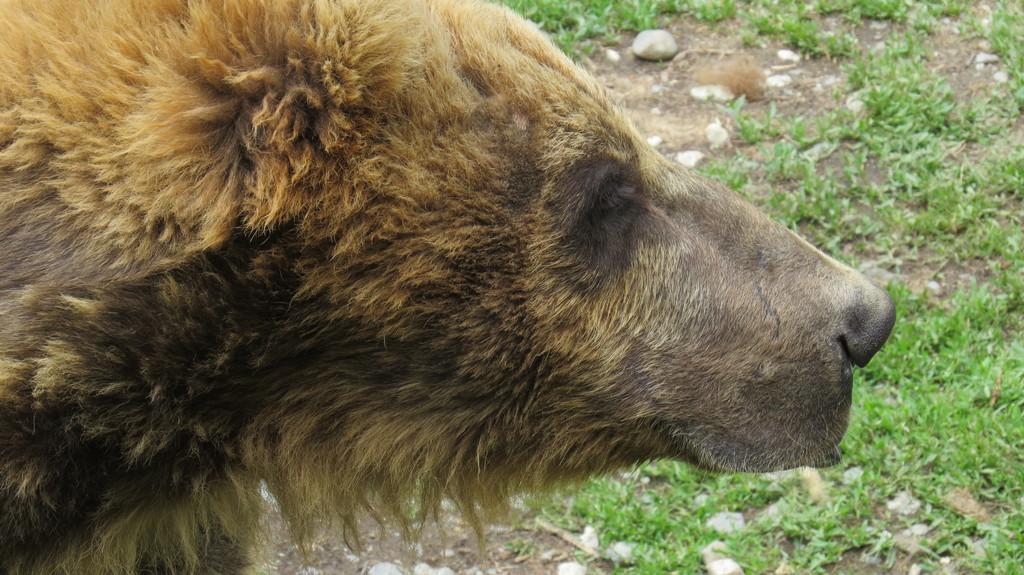Describe this image in one or two sentences. In this picture, we can see an animal, and the ground with grass, and stones. 